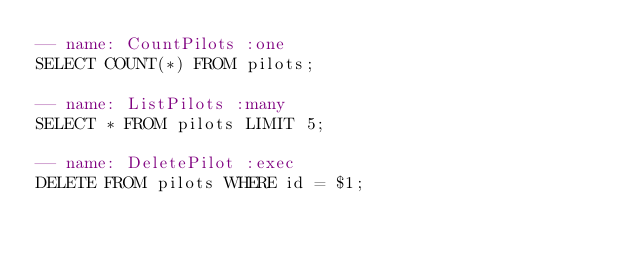Convert code to text. <code><loc_0><loc_0><loc_500><loc_500><_SQL_>-- name: CountPilots :one
SELECT COUNT(*) FROM pilots;

-- name: ListPilots :many
SELECT * FROM pilots LIMIT 5;

-- name: DeletePilot :exec
DELETE FROM pilots WHERE id = $1;
</code> 